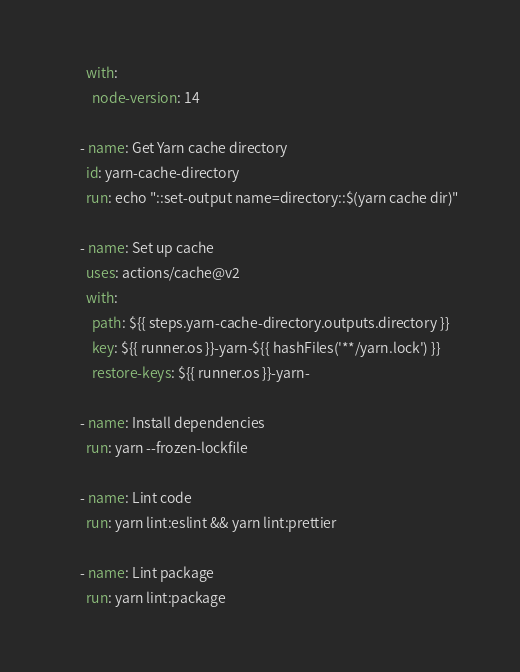Convert code to text. <code><loc_0><loc_0><loc_500><loc_500><_YAML_>        with:
          node-version: 14

      - name: Get Yarn cache directory
        id: yarn-cache-directory
        run: echo "::set-output name=directory::$(yarn cache dir)"

      - name: Set up cache
        uses: actions/cache@v2
        with:
          path: ${{ steps.yarn-cache-directory.outputs.directory }}
          key: ${{ runner.os }}-yarn-${{ hashFiles('**/yarn.lock') }}
          restore-keys: ${{ runner.os }}-yarn-

      - name: Install dependencies
        run: yarn --frozen-lockfile

      - name: Lint code
        run: yarn lint:eslint && yarn lint:prettier

      - name: Lint package
        run: yarn lint:package
</code> 